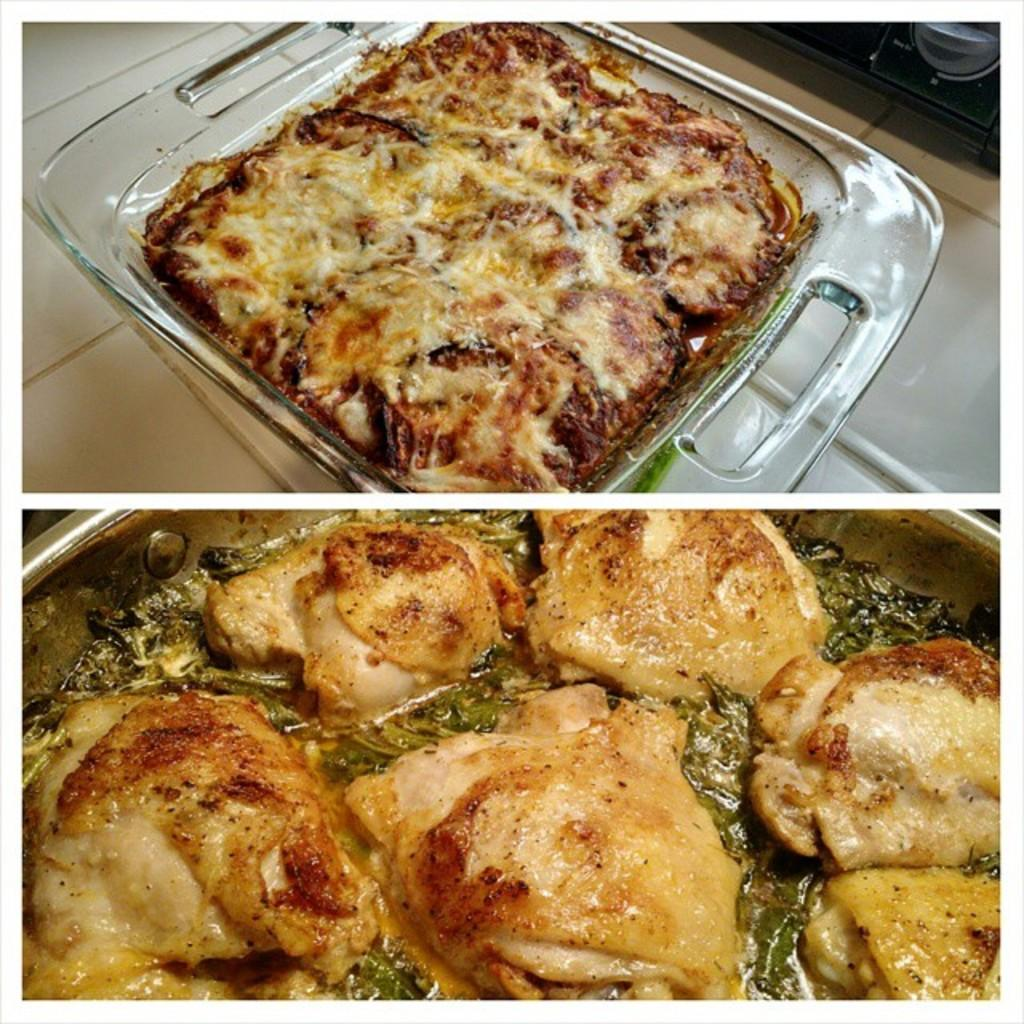What type of image is shown in the picture? The image is a photo collage. What kind of objects can be seen in the image? There are food items in the image. What type of authority is depicted in the image? There is no authority figure present in the image; it features a photo collage of food items. What historical event is being commemorated in the image? There is no historical event being commemorated in the image; it features a photo collage of food items. 